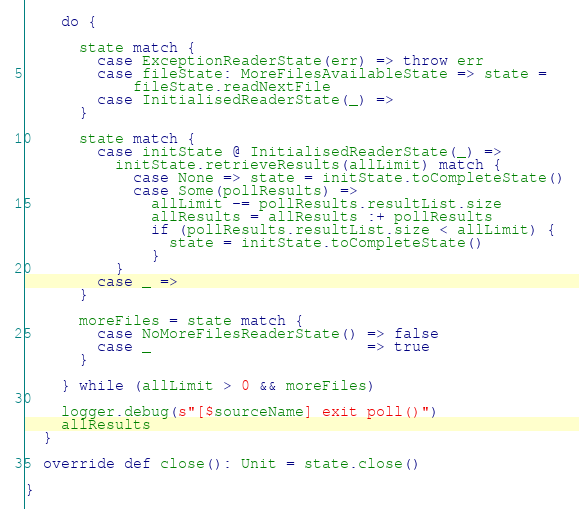<code> <loc_0><loc_0><loc_500><loc_500><_Scala_>    do {

      state match {
        case ExceptionReaderState(err) => throw err
        case fileState: MoreFilesAvailableState => state =
            fileState.readNextFile
        case InitialisedReaderState(_) =>
      }

      state match {
        case initState @ InitialisedReaderState(_) =>
          initState.retrieveResults(allLimit) match {
            case None => state = initState.toCompleteState()
            case Some(pollResults) =>
              allLimit -= pollResults.resultList.size
              allResults = allResults :+ pollResults
              if (pollResults.resultList.size < allLimit) {
                state = initState.toCompleteState()
              }
          }
        case _ =>
      }

      moreFiles = state match {
        case NoMoreFilesReaderState() => false
        case _                        => true
      }

    } while (allLimit > 0 && moreFiles)

    logger.debug(s"[$sourceName] exit poll()")
    allResults
  }

  override def close(): Unit = state.close()

}
</code> 